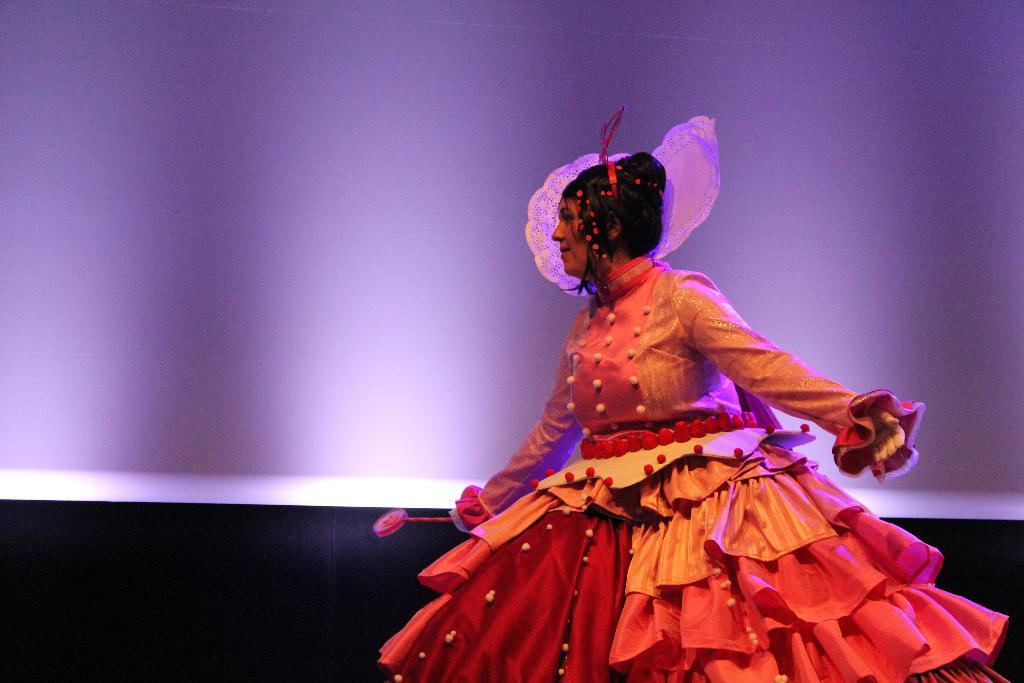What is happening in the foreground of the image? There is a woman on the stage in the foreground of the image. What can be seen in the background of the image? There is a wall in the background of the image. What is the color of the wall in the image? The wall is purple in color. What historical event is being discussed during the recess in the image? There is no recess or discussion of historical events present in the image; it features a woman on a stage with a purple wall in the background. 